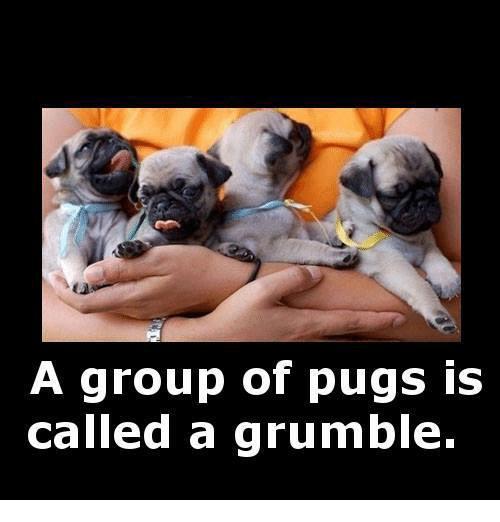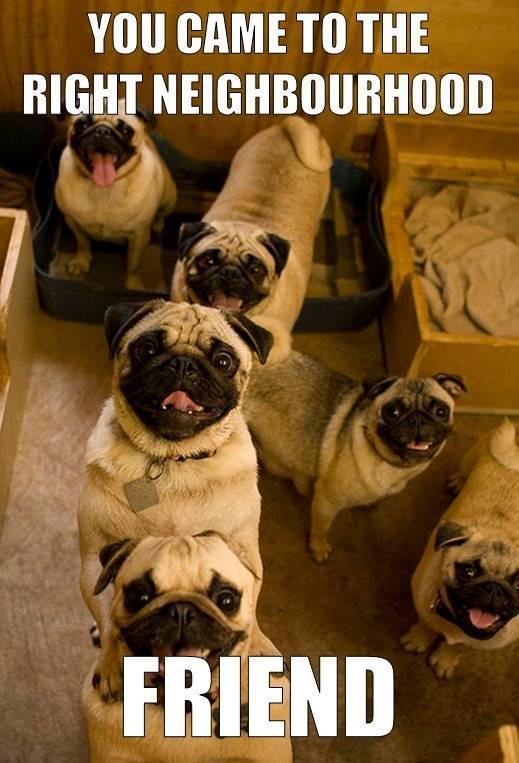The first image is the image on the left, the second image is the image on the right. Given the left and right images, does the statement "One picture has exactly three pugs." hold true? Answer yes or no. No. 